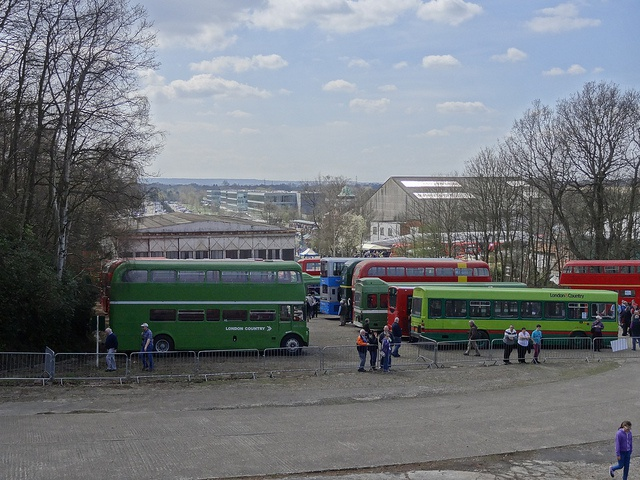Describe the objects in this image and their specific colors. I can see bus in black, darkgreen, gray, and teal tones, bus in black, darkgreen, teal, and green tones, people in black, gray, navy, and darkgray tones, bus in black, maroon, gray, and darkgray tones, and bus in black, maroon, brown, and gray tones in this image. 